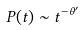<formula> <loc_0><loc_0><loc_500><loc_500>P ( t ) \sim t ^ { - \theta ^ { \prime } }</formula> 